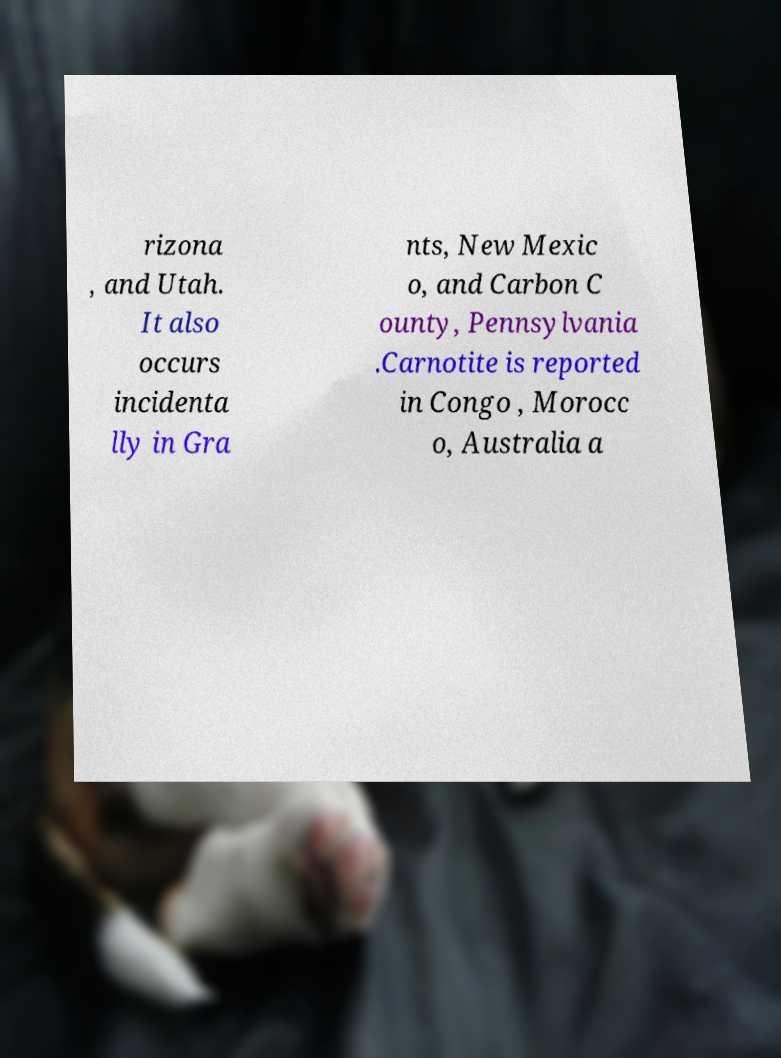Can you read and provide the text displayed in the image?This photo seems to have some interesting text. Can you extract and type it out for me? rizona , and Utah. It also occurs incidenta lly in Gra nts, New Mexic o, and Carbon C ounty, Pennsylvania .Carnotite is reported in Congo , Morocc o, Australia a 